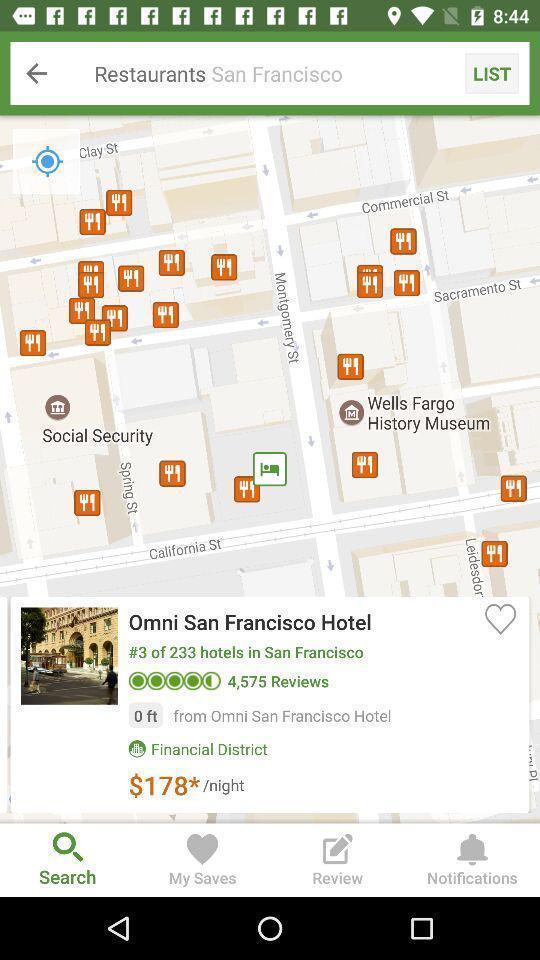Provide a description of this screenshot. Search bar to find restaurants. 